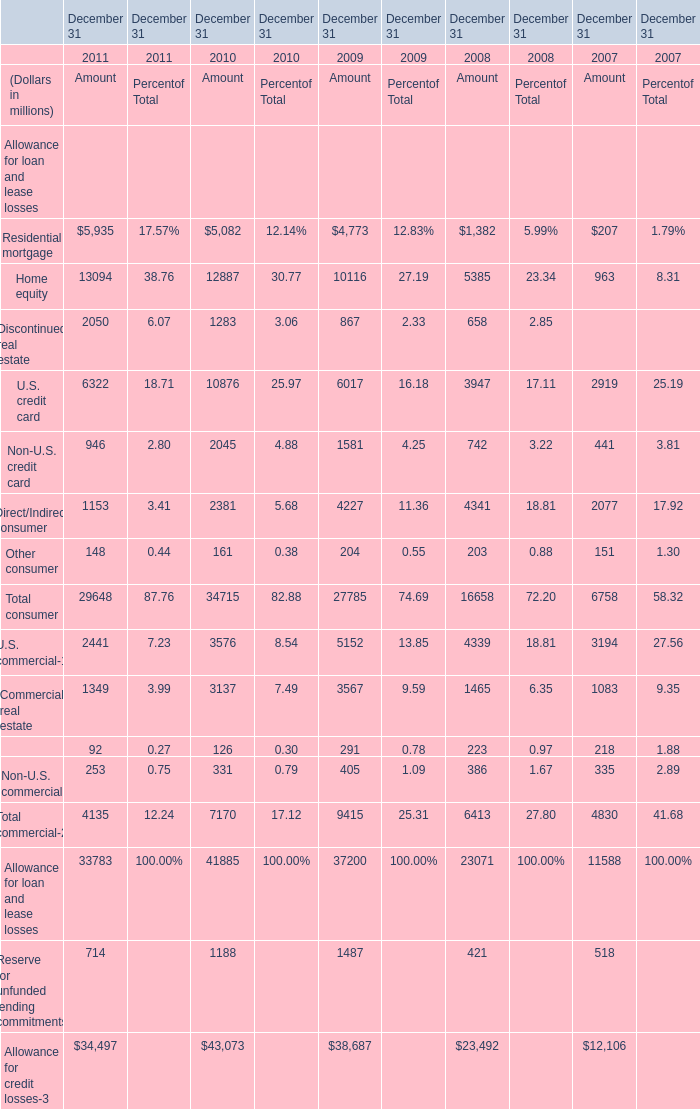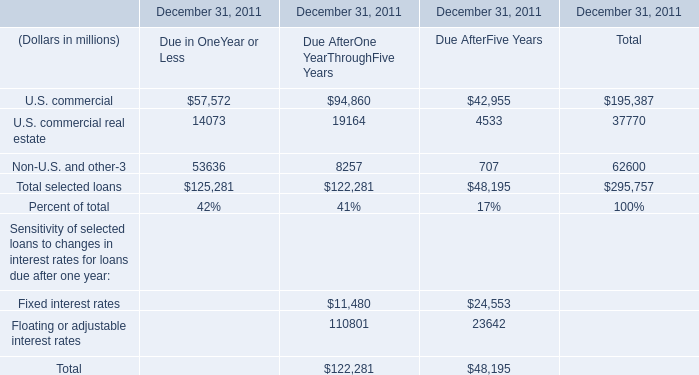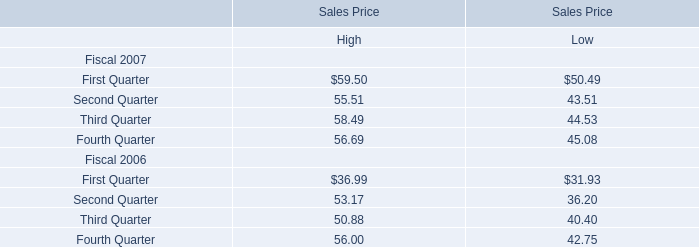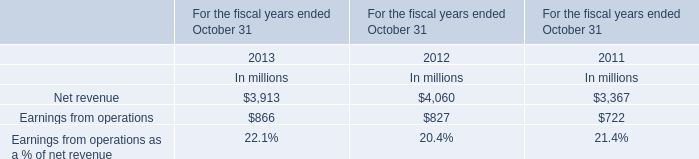What's the sum of Home equity of December 31 2010 Amount, U.S. commercial of December 31, 2011 Due AfterOne YearThroughFive Years, and Total selected loans of December 31, 2011 Total ? 
Computations: ((12887.0 + 94860.0) + 295757.0)
Answer: 403504.0. 